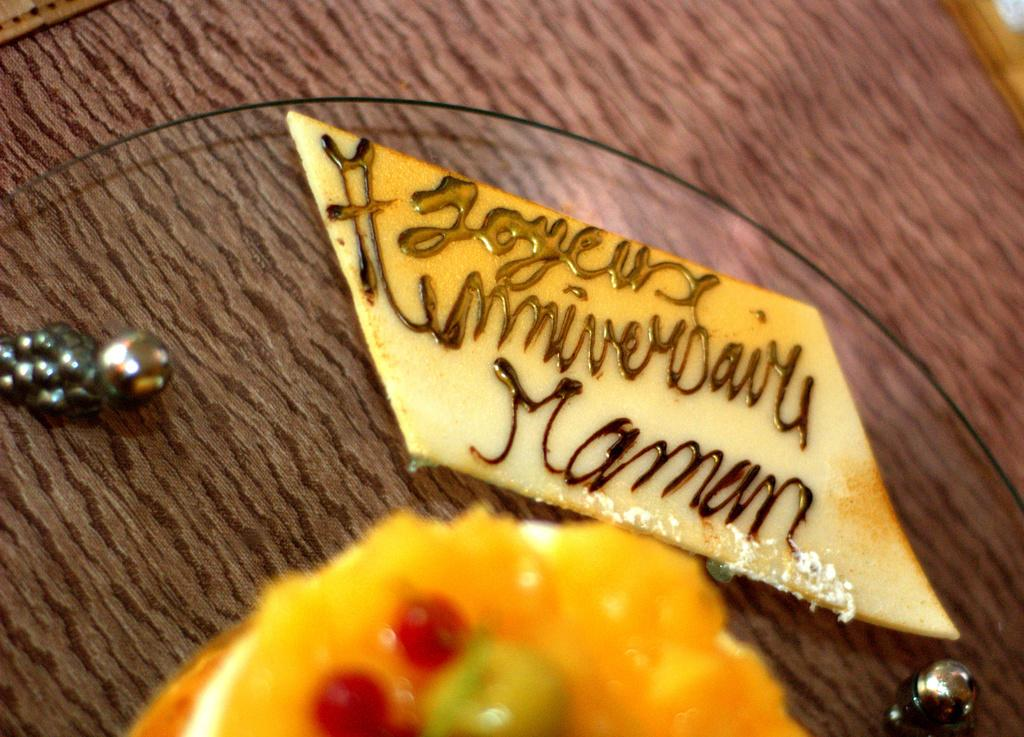What is the main piece of furniture in the image? There is a table in the image. What is placed on the table? A cake is placed on the table. Are there any other objects on the table besides the cake? Yes, there are other objects on the table. What is the color of the object with text on it? The object with text on it is white. How does the cake stop moving in the image? The cake does not move in the image; it is stationary on the table. 